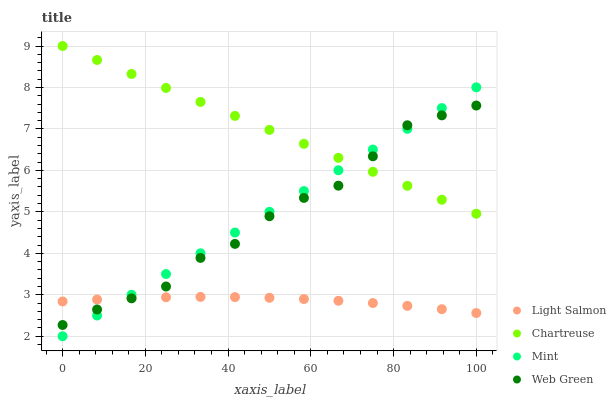Does Light Salmon have the minimum area under the curve?
Answer yes or no. Yes. Does Chartreuse have the maximum area under the curve?
Answer yes or no. Yes. Does Mint have the minimum area under the curve?
Answer yes or no. No. Does Mint have the maximum area under the curve?
Answer yes or no. No. Is Mint the smoothest?
Answer yes or no. Yes. Is Web Green the roughest?
Answer yes or no. Yes. Is Chartreuse the smoothest?
Answer yes or no. No. Is Chartreuse the roughest?
Answer yes or no. No. Does Mint have the lowest value?
Answer yes or no. Yes. Does Chartreuse have the lowest value?
Answer yes or no. No. Does Chartreuse have the highest value?
Answer yes or no. Yes. Does Mint have the highest value?
Answer yes or no. No. Is Light Salmon less than Chartreuse?
Answer yes or no. Yes. Is Chartreuse greater than Light Salmon?
Answer yes or no. Yes. Does Light Salmon intersect Web Green?
Answer yes or no. Yes. Is Light Salmon less than Web Green?
Answer yes or no. No. Is Light Salmon greater than Web Green?
Answer yes or no. No. Does Light Salmon intersect Chartreuse?
Answer yes or no. No. 